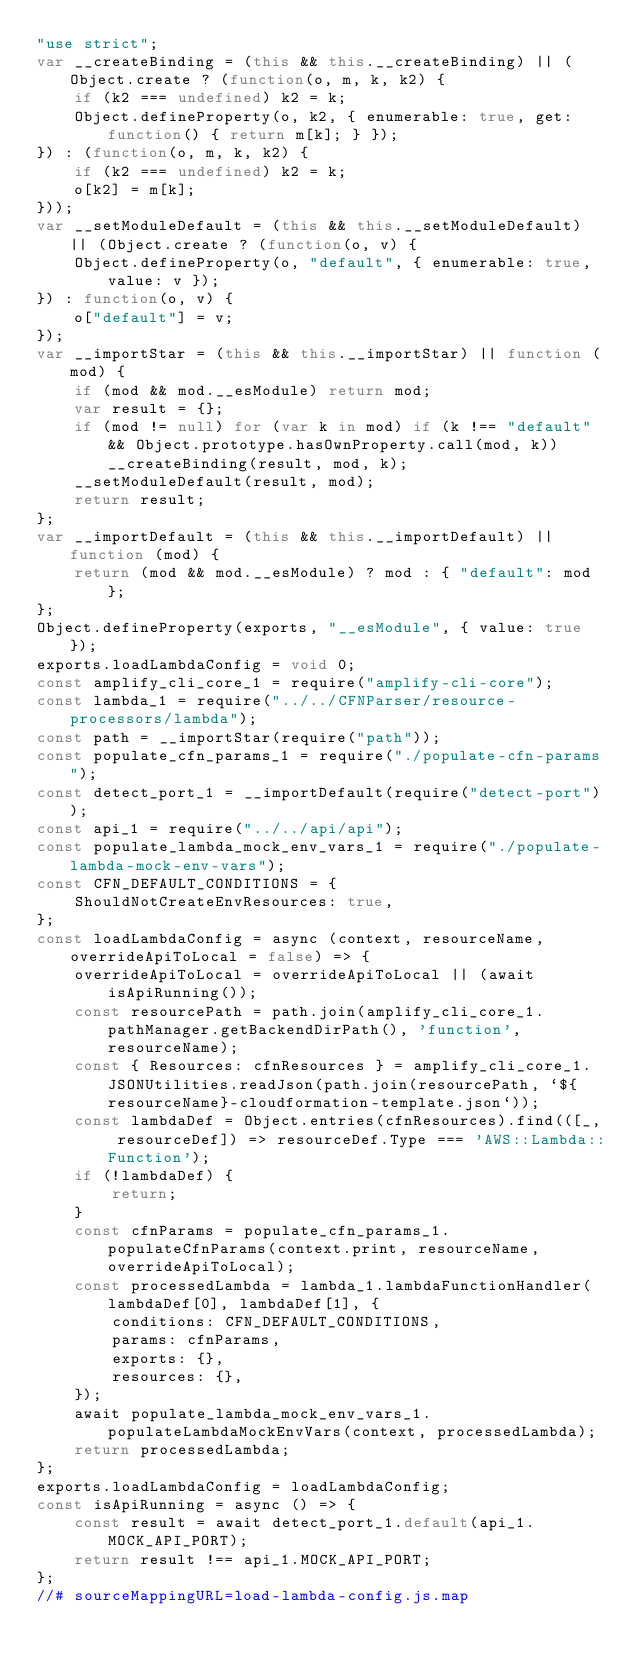<code> <loc_0><loc_0><loc_500><loc_500><_JavaScript_>"use strict";
var __createBinding = (this && this.__createBinding) || (Object.create ? (function(o, m, k, k2) {
    if (k2 === undefined) k2 = k;
    Object.defineProperty(o, k2, { enumerable: true, get: function() { return m[k]; } });
}) : (function(o, m, k, k2) {
    if (k2 === undefined) k2 = k;
    o[k2] = m[k];
}));
var __setModuleDefault = (this && this.__setModuleDefault) || (Object.create ? (function(o, v) {
    Object.defineProperty(o, "default", { enumerable: true, value: v });
}) : function(o, v) {
    o["default"] = v;
});
var __importStar = (this && this.__importStar) || function (mod) {
    if (mod && mod.__esModule) return mod;
    var result = {};
    if (mod != null) for (var k in mod) if (k !== "default" && Object.prototype.hasOwnProperty.call(mod, k)) __createBinding(result, mod, k);
    __setModuleDefault(result, mod);
    return result;
};
var __importDefault = (this && this.__importDefault) || function (mod) {
    return (mod && mod.__esModule) ? mod : { "default": mod };
};
Object.defineProperty(exports, "__esModule", { value: true });
exports.loadLambdaConfig = void 0;
const amplify_cli_core_1 = require("amplify-cli-core");
const lambda_1 = require("../../CFNParser/resource-processors/lambda");
const path = __importStar(require("path"));
const populate_cfn_params_1 = require("./populate-cfn-params");
const detect_port_1 = __importDefault(require("detect-port"));
const api_1 = require("../../api/api");
const populate_lambda_mock_env_vars_1 = require("./populate-lambda-mock-env-vars");
const CFN_DEFAULT_CONDITIONS = {
    ShouldNotCreateEnvResources: true,
};
const loadLambdaConfig = async (context, resourceName, overrideApiToLocal = false) => {
    overrideApiToLocal = overrideApiToLocal || (await isApiRunning());
    const resourcePath = path.join(amplify_cli_core_1.pathManager.getBackendDirPath(), 'function', resourceName);
    const { Resources: cfnResources } = amplify_cli_core_1.JSONUtilities.readJson(path.join(resourcePath, `${resourceName}-cloudformation-template.json`));
    const lambdaDef = Object.entries(cfnResources).find(([_, resourceDef]) => resourceDef.Type === 'AWS::Lambda::Function');
    if (!lambdaDef) {
        return;
    }
    const cfnParams = populate_cfn_params_1.populateCfnParams(context.print, resourceName, overrideApiToLocal);
    const processedLambda = lambda_1.lambdaFunctionHandler(lambdaDef[0], lambdaDef[1], {
        conditions: CFN_DEFAULT_CONDITIONS,
        params: cfnParams,
        exports: {},
        resources: {},
    });
    await populate_lambda_mock_env_vars_1.populateLambdaMockEnvVars(context, processedLambda);
    return processedLambda;
};
exports.loadLambdaConfig = loadLambdaConfig;
const isApiRunning = async () => {
    const result = await detect_port_1.default(api_1.MOCK_API_PORT);
    return result !== api_1.MOCK_API_PORT;
};
//# sourceMappingURL=load-lambda-config.js.map</code> 